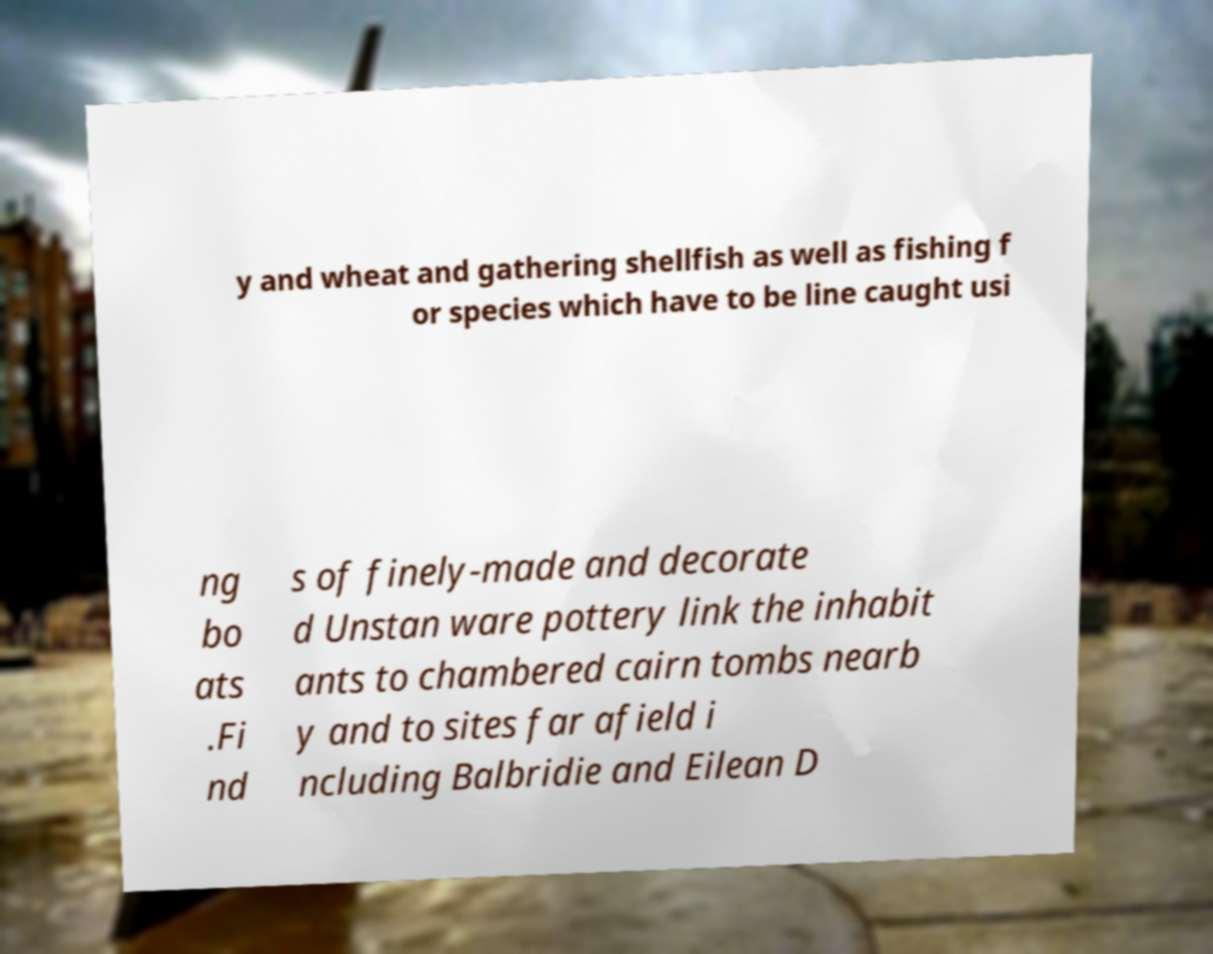Can you read and provide the text displayed in the image?This photo seems to have some interesting text. Can you extract and type it out for me? y and wheat and gathering shellfish as well as fishing f or species which have to be line caught usi ng bo ats .Fi nd s of finely-made and decorate d Unstan ware pottery link the inhabit ants to chambered cairn tombs nearb y and to sites far afield i ncluding Balbridie and Eilean D 